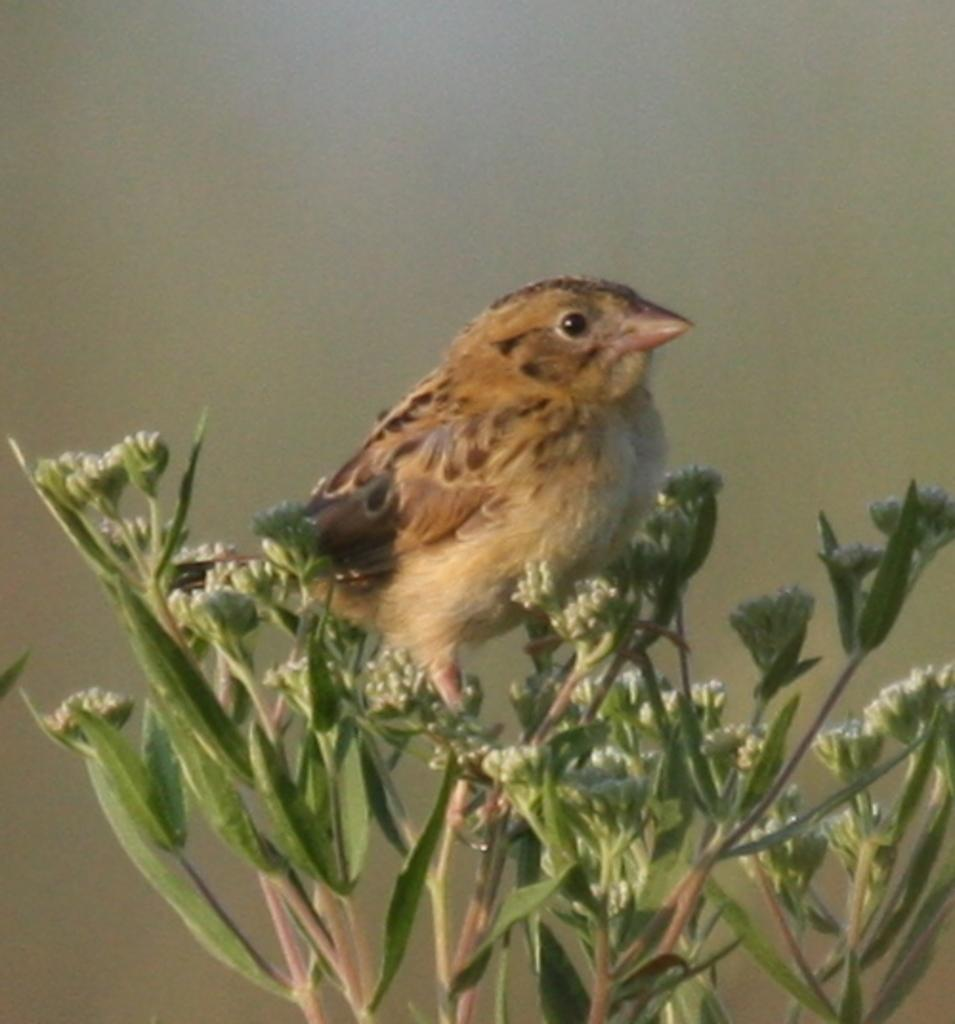What type of living organism can be seen in the image? There is a plant in the image. What animal is present in the image? There is a bird in the image. Can you describe the background of the image? The background of the image is blurred. Where is the hose connected to the basin in the image? There is no hose or basin present in the image. What type of book is the bird reading in the image? There is no book present in the image; the bird is not shown reading anything. 